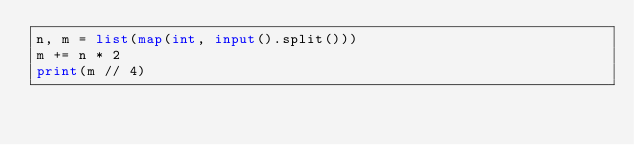Convert code to text. <code><loc_0><loc_0><loc_500><loc_500><_Python_>n, m = list(map(int, input().split()))
m += n * 2
print(m // 4)</code> 